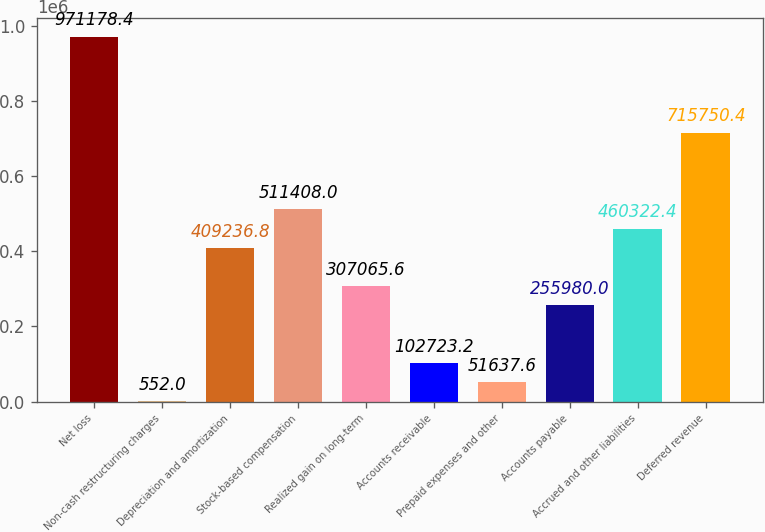<chart> <loc_0><loc_0><loc_500><loc_500><bar_chart><fcel>Net loss<fcel>Non-cash restructuring charges<fcel>Depreciation and amortization<fcel>Stock-based compensation<fcel>Realized gain on long-term<fcel>Accounts receivable<fcel>Prepaid expenses and other<fcel>Accounts payable<fcel>Accrued and other liabilities<fcel>Deferred revenue<nl><fcel>971178<fcel>552<fcel>409237<fcel>511408<fcel>307066<fcel>102723<fcel>51637.6<fcel>255980<fcel>460322<fcel>715750<nl></chart> 